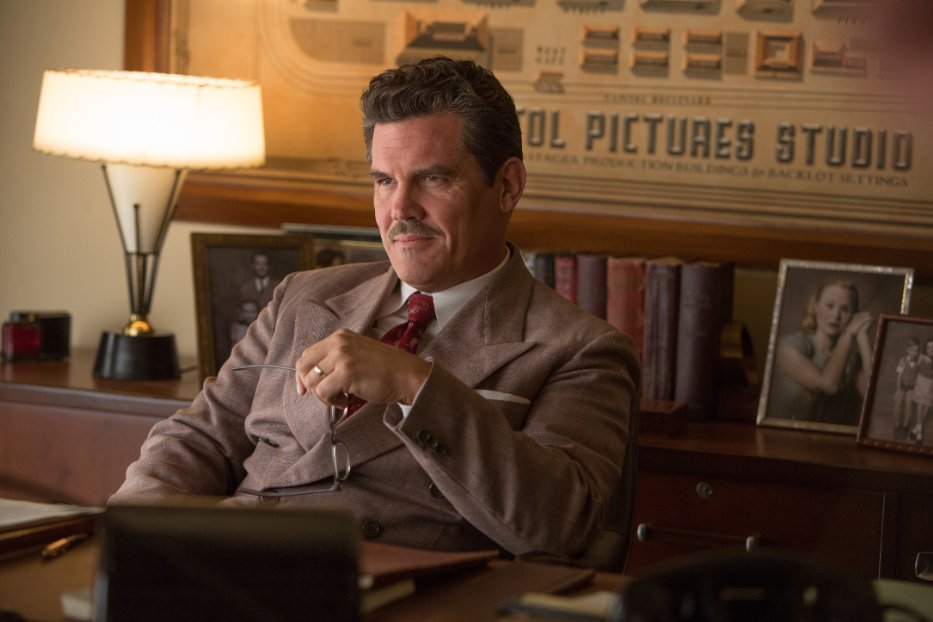What's happening in the scene? In this scene, we observe an actor, specifically Josh Brolin, portraying the character Eddie Mannix from the film 'Hail, Caesar!'. He is positioned at a desk in an office that has a distinct vintage ambiance, emphasized by the wood-paneled walls. The office is decorated with a lamp and framed photographs, enhancing its historic charm. Brolin, dressed in a maroon suit, has a mustache that suits his role. He is holding a cigar and looks deep in thought, suggesting he is contemplating a difficult decision or solving a complex issue. 